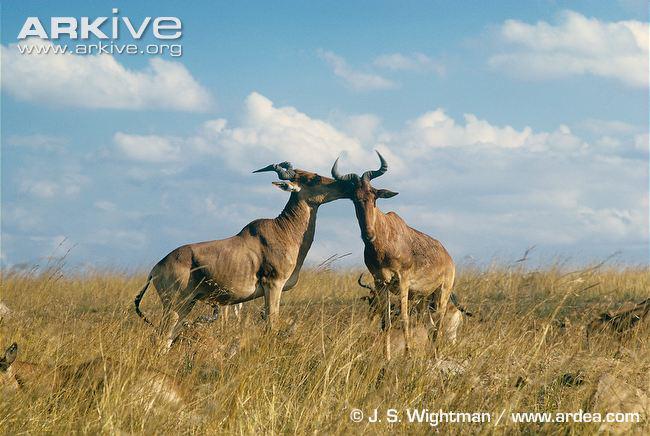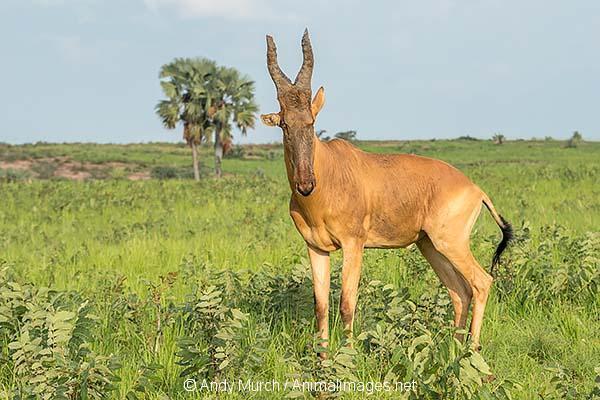The first image is the image on the left, the second image is the image on the right. Examine the images to the left and right. Is the description "Each image contains a single horned animal, which is standing on all four legs with its body in profile." accurate? Answer yes or no. No. The first image is the image on the left, the second image is the image on the right. For the images shown, is this caption "There are exactly two goats." true? Answer yes or no. No. 